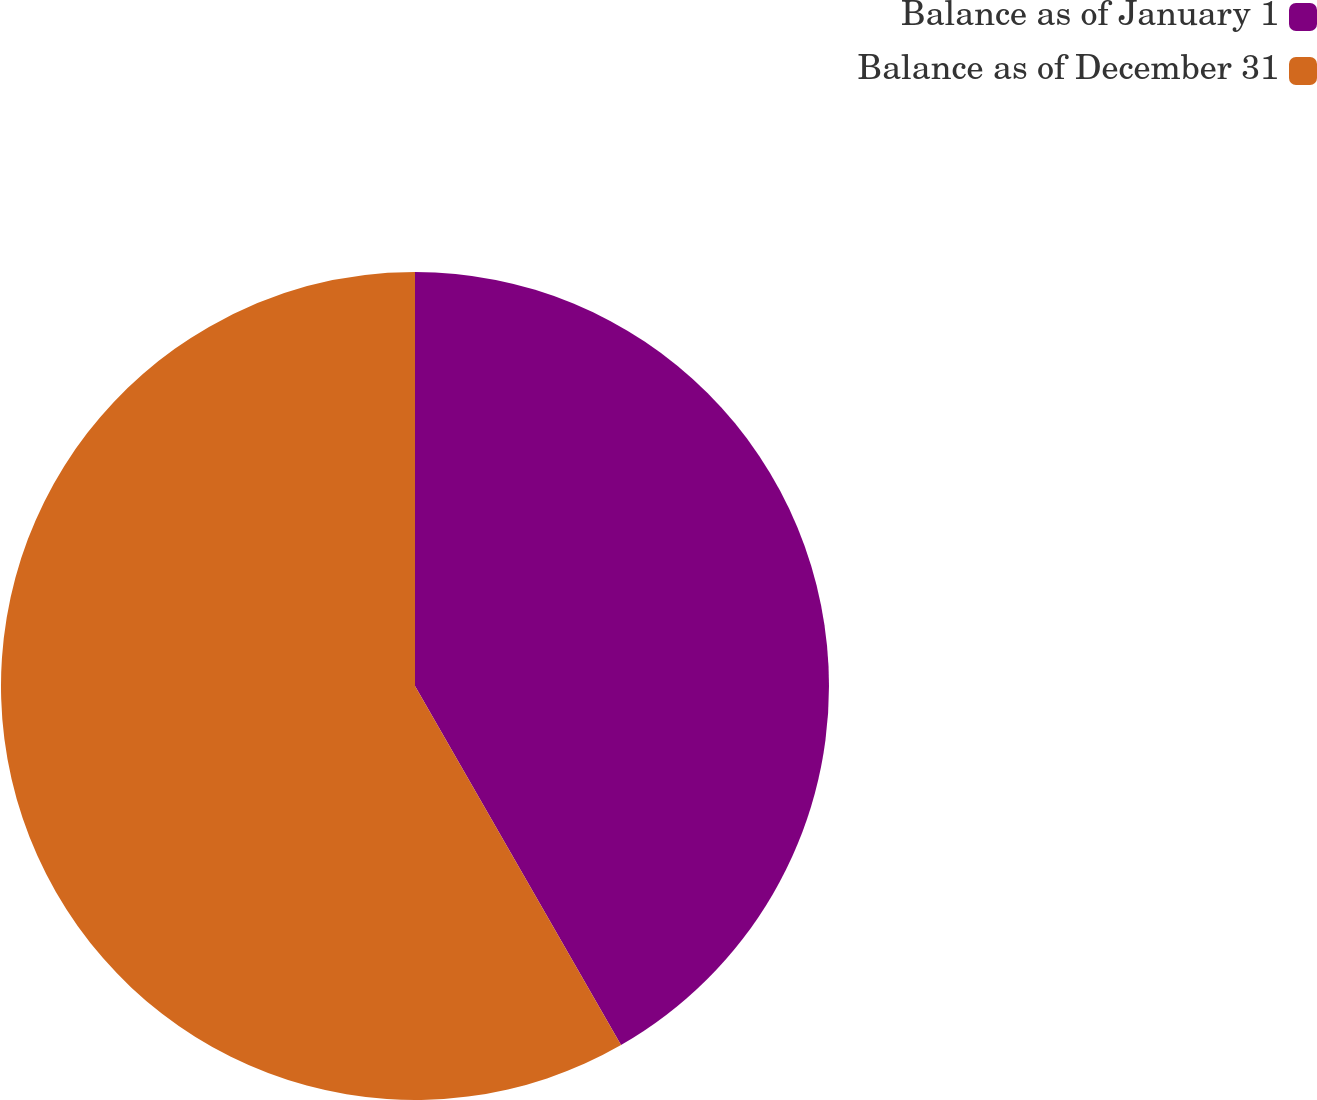<chart> <loc_0><loc_0><loc_500><loc_500><pie_chart><fcel>Balance as of January 1<fcel>Balance as of December 31<nl><fcel>41.71%<fcel>58.29%<nl></chart> 